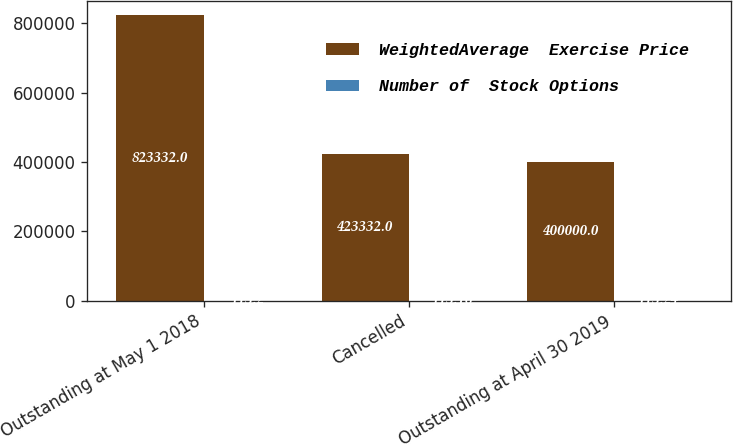<chart> <loc_0><loc_0><loc_500><loc_500><stacked_bar_chart><ecel><fcel>Outstanding at May 1 2018<fcel>Cancelled<fcel>Outstanding at April 30 2019<nl><fcel>WeightedAverage  Exercise Price<fcel>823332<fcel>423332<fcel>400000<nl><fcel>Number of  Stock Options<fcel>113.2<fcel>113.16<fcel>113.24<nl></chart> 